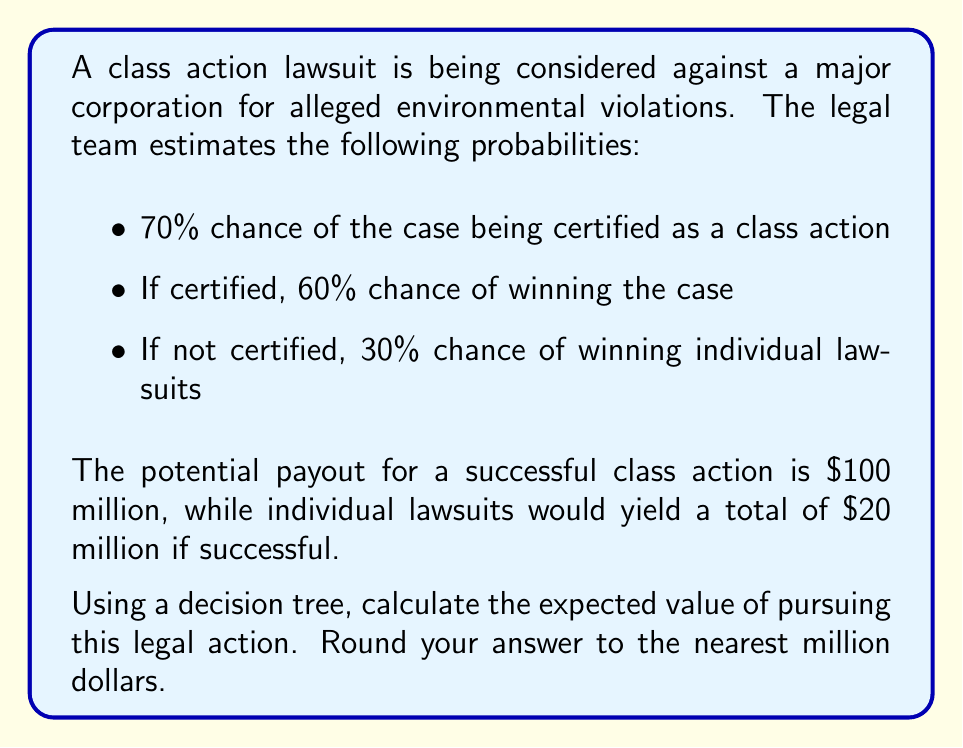Can you answer this question? Let's approach this problem using a decision tree:

1. First, we need to calculate the probabilities and payouts for each branch:

   a. Class action certified and won:
      Probability: $0.70 \times 0.60 = 0.42$
      Payout: $100 million

   b. Class action certified but lost:
      Probability: $0.70 \times 0.40 = 0.28$
      Payout: $0

   c. Not certified, individual lawsuits won:
      Probability: $0.30 \times 0.30 = 0.09$
      Payout: $20 million

   d. Not certified, individual lawsuits lost:
      Probability: $0.30 \times 0.70 = 0.21$
      Payout: $0

2. Now, we calculate the expected value for each outcome:

   a. $0.42 \times \$100,000,000 = \$42,000,000$
   b. $0.28 \times \$0 = \$0$
   c. $0.09 \times \$20,000,000 = \$1,800,000$
   d. $0.21 \times \$0 = \$0$

3. The total expected value is the sum of all these outcomes:

   $$\$42,000,000 + \$0 + \$1,800,000 + \$0 = \$43,800,000$$

4. Rounding to the nearest million:

   $$\$43,800,000 \approx \$44,000,000$$

This decision tree analysis shows that the expected value of pursuing this legal action is $44 million.
Answer: $44 million 